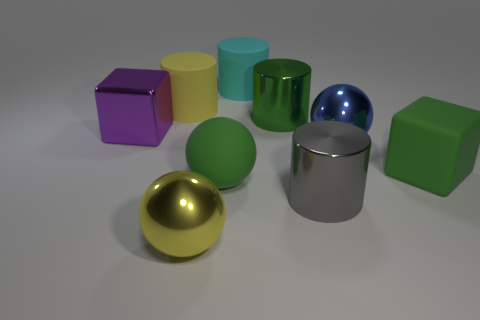There is a metal object that is the same color as the big rubber cube; what is its shape?
Offer a very short reply. Cylinder. What is the shape of the gray shiny object?
Offer a very short reply. Cylinder. How many large green metal things are there?
Give a very brief answer. 1. There is a block on the right side of the green thing that is behind the big rubber block; what is its color?
Your answer should be compact. Green. There is a shiny cube that is the same size as the rubber block; what is its color?
Your response must be concise. Purple. Are there any large rubber things that have the same color as the big shiny cube?
Offer a very short reply. No. Are any tiny cyan metal things visible?
Ensure brevity in your answer.  No. The yellow thing behind the large green ball has what shape?
Provide a short and direct response. Cylinder. What number of things are both left of the cyan rubber thing and on the right side of the large purple cube?
Ensure brevity in your answer.  3. What number of other things are the same size as the blue shiny object?
Provide a short and direct response. 8. 